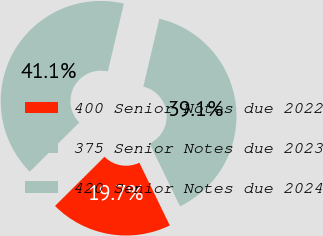Convert chart to OTSL. <chart><loc_0><loc_0><loc_500><loc_500><pie_chart><fcel>400 Senior Notes due 2022<fcel>375 Senior Notes due 2023<fcel>420 Senior Notes due 2024<nl><fcel>19.74%<fcel>39.12%<fcel>41.14%<nl></chart> 